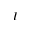Convert formula to latex. <formula><loc_0><loc_0><loc_500><loc_500>I</formula> 